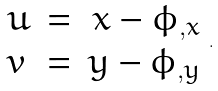Convert formula to latex. <formula><loc_0><loc_0><loc_500><loc_500>\begin{array} { l c r } u & = & x - \phi _ { , x } \\ v & = & y - \phi _ { , y } \end{array} .</formula> 